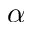Convert formula to latex. <formula><loc_0><loc_0><loc_500><loc_500>\alpha</formula> 